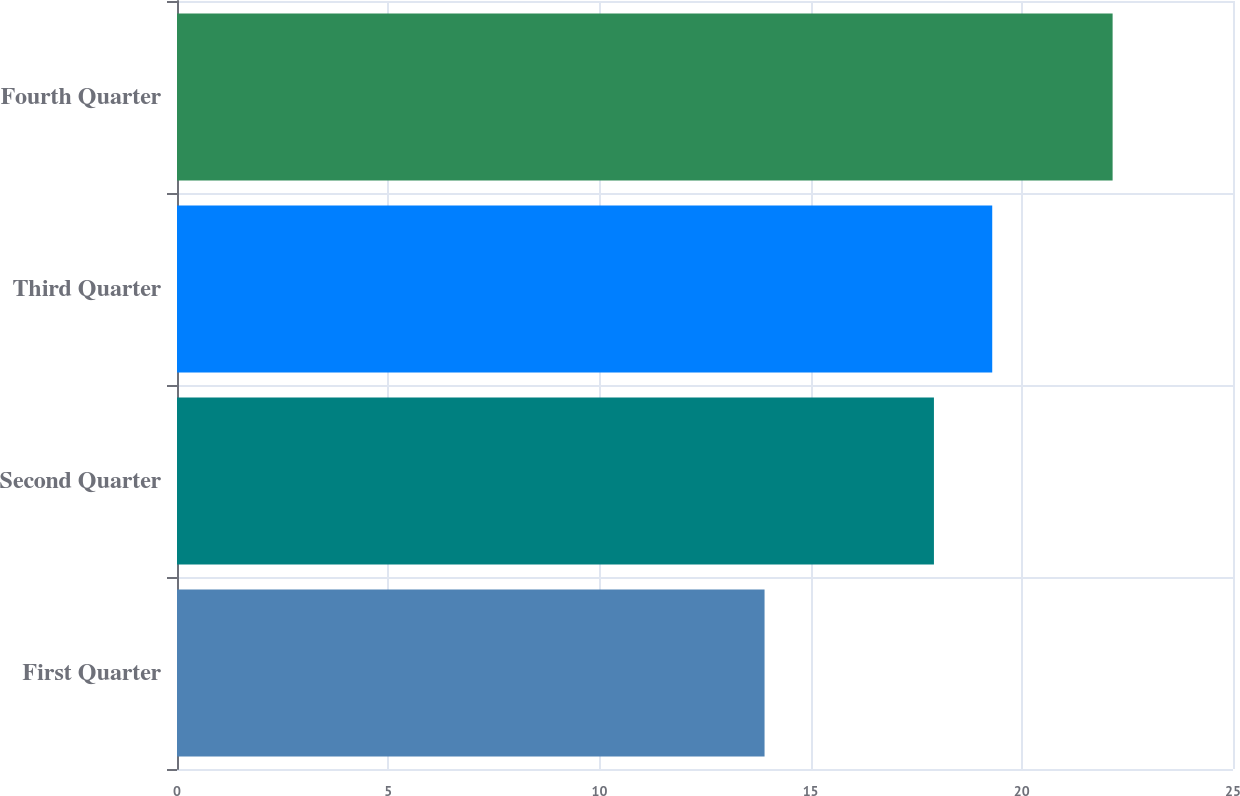<chart> <loc_0><loc_0><loc_500><loc_500><bar_chart><fcel>First Quarter<fcel>Second Quarter<fcel>Third Quarter<fcel>Fourth Quarter<nl><fcel>13.91<fcel>17.92<fcel>19.3<fcel>22.15<nl></chart> 